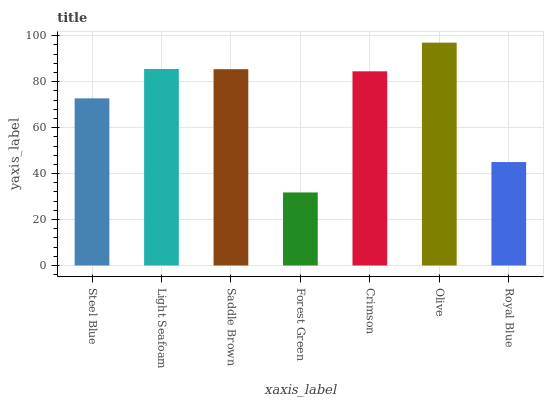Is Forest Green the minimum?
Answer yes or no. Yes. Is Olive the maximum?
Answer yes or no. Yes. Is Light Seafoam the minimum?
Answer yes or no. No. Is Light Seafoam the maximum?
Answer yes or no. No. Is Light Seafoam greater than Steel Blue?
Answer yes or no. Yes. Is Steel Blue less than Light Seafoam?
Answer yes or no. Yes. Is Steel Blue greater than Light Seafoam?
Answer yes or no. No. Is Light Seafoam less than Steel Blue?
Answer yes or no. No. Is Crimson the high median?
Answer yes or no. Yes. Is Crimson the low median?
Answer yes or no. Yes. Is Royal Blue the high median?
Answer yes or no. No. Is Light Seafoam the low median?
Answer yes or no. No. 